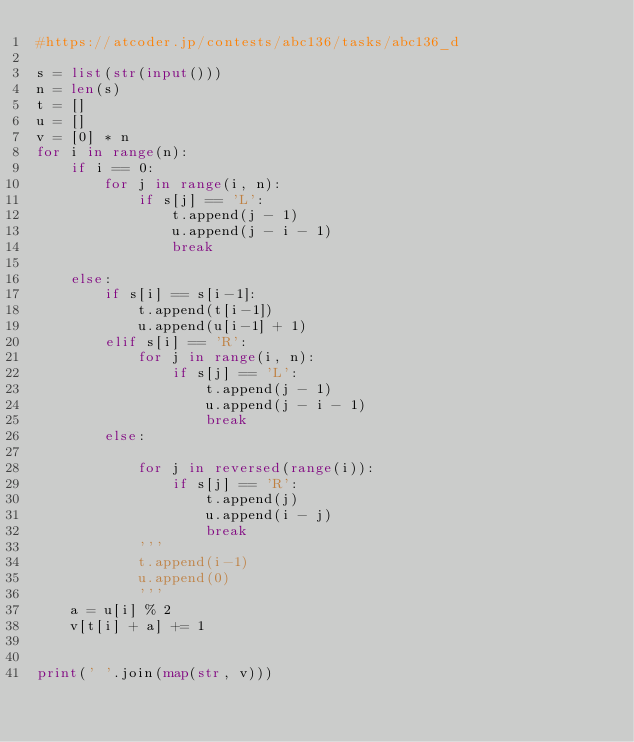Convert code to text. <code><loc_0><loc_0><loc_500><loc_500><_Python_>#https://atcoder.jp/contests/abc136/tasks/abc136_d

s = list(str(input()))
n = len(s)
t = []
u = []
v = [0] * n
for i in range(n):
    if i == 0:
        for j in range(i, n):
            if s[j] == 'L':
                t.append(j - 1)
                u.append(j - i - 1)
                break

    else:
        if s[i] == s[i-1]:
            t.append(t[i-1])
            u.append(u[i-1] + 1)
        elif s[i] == 'R':
            for j in range(i, n):
                if s[j] == 'L':
                    t.append(j - 1)
                    u.append(j - i - 1)
                    break
        else:
            
            for j in reversed(range(i)):
                if s[j] == 'R':
                    t.append(j)
                    u.append(i - j)
                    break
            '''
            t.append(i-1)
            u.append(0)
            '''
    a = u[i] % 2
    v[t[i] + a] += 1


print(' '.join(map(str, v)))
</code> 